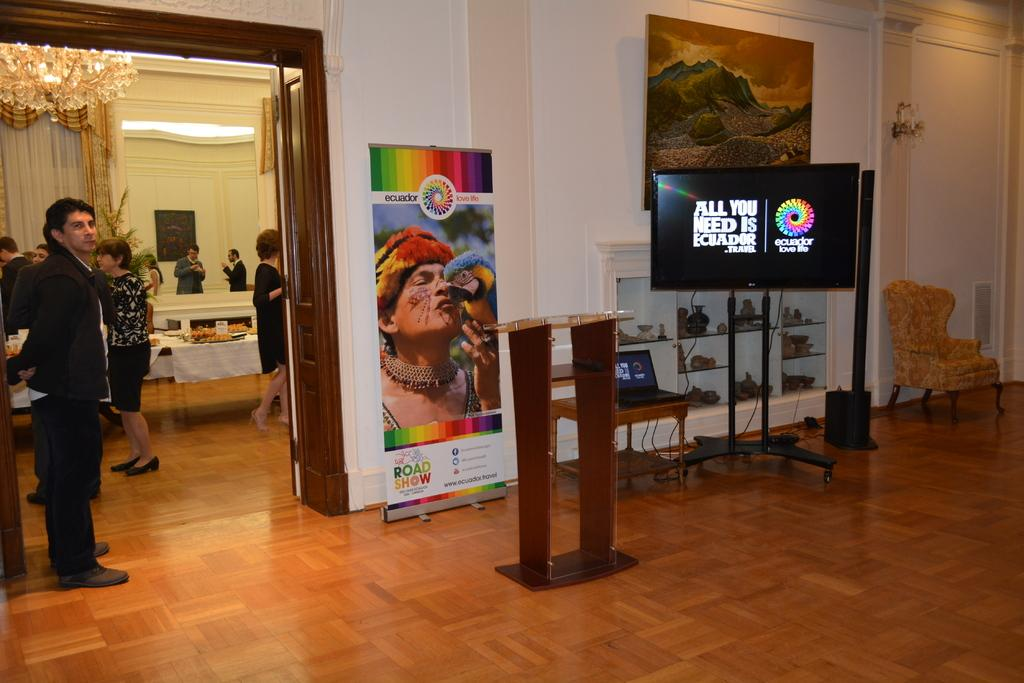<image>
Provide a brief description of the given image. a tv screen inside of a building that says 'all you need is ecuador - travel' 